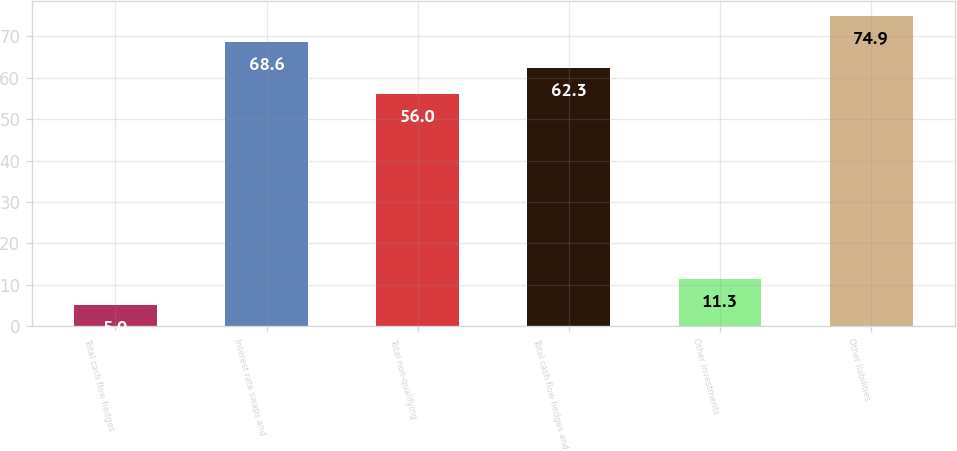Convert chart. <chart><loc_0><loc_0><loc_500><loc_500><bar_chart><fcel>Total cash flow hedges<fcel>Interest rate swaps and<fcel>Total non-qualifying<fcel>Total cash flow hedges and<fcel>Other investments<fcel>Other liabilities<nl><fcel>5<fcel>68.6<fcel>56<fcel>62.3<fcel>11.3<fcel>74.9<nl></chart> 